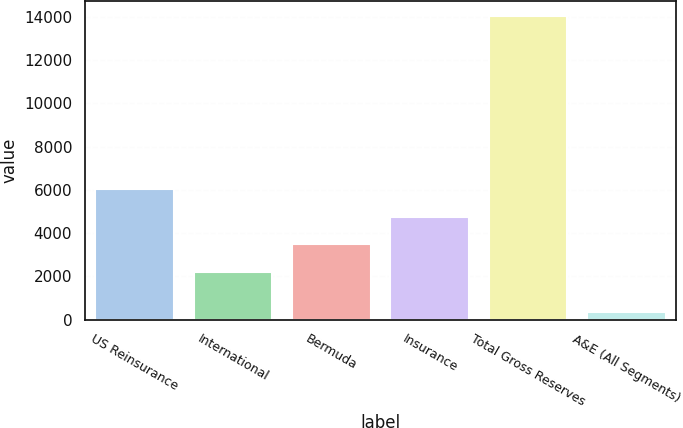Convert chart to OTSL. <chart><loc_0><loc_0><loc_500><loc_500><bar_chart><fcel>US Reinsurance<fcel>International<fcel>Bermuda<fcel>Insurance<fcel>Total Gross Reserves<fcel>A&E (All Segments)<nl><fcel>6036.18<fcel>2204.7<fcel>3481.86<fcel>4759.02<fcel>14048.8<fcel>347.5<nl></chart> 